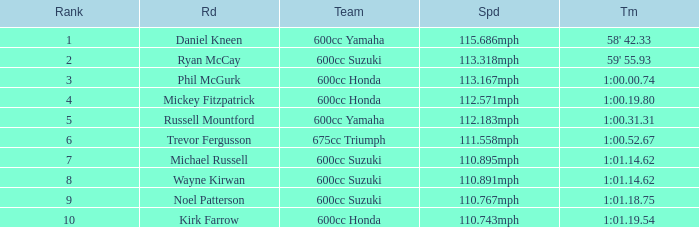How many ranks have michael russell as the rider? 7.0. 